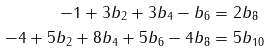Convert formula to latex. <formula><loc_0><loc_0><loc_500><loc_500>- 1 + 3 b _ { 2 } + 3 b _ { 4 } - b _ { 6 } & = 2 b _ { 8 } \\ - 4 + 5 b _ { 2 } + 8 b _ { 4 } + 5 b _ { 6 } - 4 b _ { 8 } & = 5 b _ { 1 0 }</formula> 